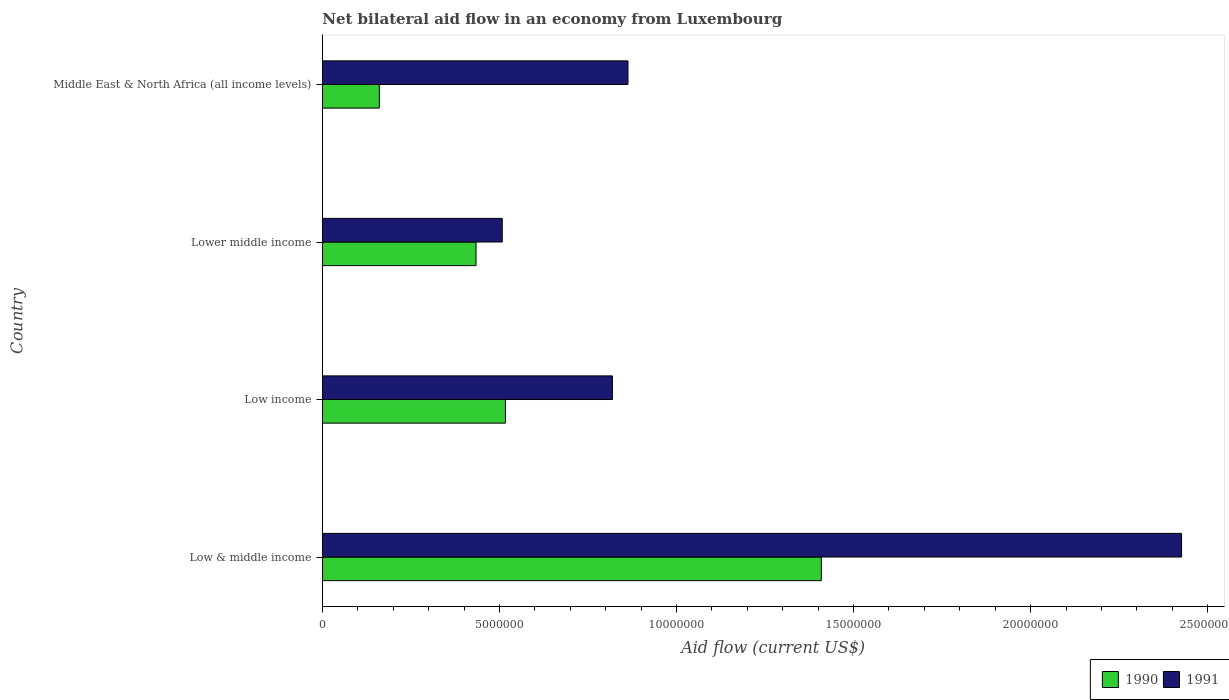How many bars are there on the 3rd tick from the bottom?
Provide a short and direct response. 2. What is the label of the 2nd group of bars from the top?
Your answer should be very brief. Lower middle income. What is the net bilateral aid flow in 1991 in Middle East & North Africa (all income levels)?
Your answer should be very brief. 8.63e+06. Across all countries, what is the maximum net bilateral aid flow in 1990?
Your response must be concise. 1.41e+07. Across all countries, what is the minimum net bilateral aid flow in 1991?
Provide a short and direct response. 5.08e+06. In which country was the net bilateral aid flow in 1990 minimum?
Offer a very short reply. Middle East & North Africa (all income levels). What is the total net bilateral aid flow in 1990 in the graph?
Give a very brief answer. 2.52e+07. What is the difference between the net bilateral aid flow in 1990 in Low & middle income and that in Low income?
Give a very brief answer. 8.92e+06. What is the difference between the net bilateral aid flow in 1990 in Lower middle income and the net bilateral aid flow in 1991 in Middle East & North Africa (all income levels)?
Provide a succinct answer. -4.29e+06. What is the average net bilateral aid flow in 1991 per country?
Ensure brevity in your answer.  1.15e+07. What is the difference between the net bilateral aid flow in 1991 and net bilateral aid flow in 1990 in Low income?
Your response must be concise. 3.02e+06. In how many countries, is the net bilateral aid flow in 1991 greater than 16000000 US$?
Your answer should be compact. 1. What is the ratio of the net bilateral aid flow in 1990 in Low income to that in Lower middle income?
Ensure brevity in your answer.  1.19. Is the net bilateral aid flow in 1990 in Low & middle income less than that in Lower middle income?
Offer a very short reply. No. What is the difference between the highest and the second highest net bilateral aid flow in 1990?
Ensure brevity in your answer.  8.92e+06. What is the difference between the highest and the lowest net bilateral aid flow in 1990?
Give a very brief answer. 1.25e+07. In how many countries, is the net bilateral aid flow in 1990 greater than the average net bilateral aid flow in 1990 taken over all countries?
Your answer should be compact. 1. Is the sum of the net bilateral aid flow in 1990 in Low & middle income and Lower middle income greater than the maximum net bilateral aid flow in 1991 across all countries?
Ensure brevity in your answer.  No. What does the 2nd bar from the top in Lower middle income represents?
Your answer should be compact. 1990. How many bars are there?
Offer a terse response. 8. How many countries are there in the graph?
Provide a short and direct response. 4. What is the difference between two consecutive major ticks on the X-axis?
Give a very brief answer. 5.00e+06. Does the graph contain grids?
Your response must be concise. No. Where does the legend appear in the graph?
Your response must be concise. Bottom right. How many legend labels are there?
Provide a succinct answer. 2. What is the title of the graph?
Offer a terse response. Net bilateral aid flow in an economy from Luxembourg. Does "1969" appear as one of the legend labels in the graph?
Provide a short and direct response. No. What is the label or title of the X-axis?
Offer a terse response. Aid flow (current US$). What is the label or title of the Y-axis?
Make the answer very short. Country. What is the Aid flow (current US$) of 1990 in Low & middle income?
Give a very brief answer. 1.41e+07. What is the Aid flow (current US$) in 1991 in Low & middle income?
Offer a terse response. 2.43e+07. What is the Aid flow (current US$) in 1990 in Low income?
Provide a short and direct response. 5.17e+06. What is the Aid flow (current US$) in 1991 in Low income?
Keep it short and to the point. 8.19e+06. What is the Aid flow (current US$) of 1990 in Lower middle income?
Your response must be concise. 4.34e+06. What is the Aid flow (current US$) of 1991 in Lower middle income?
Provide a succinct answer. 5.08e+06. What is the Aid flow (current US$) in 1990 in Middle East & North Africa (all income levels)?
Offer a terse response. 1.61e+06. What is the Aid flow (current US$) of 1991 in Middle East & North Africa (all income levels)?
Make the answer very short. 8.63e+06. Across all countries, what is the maximum Aid flow (current US$) of 1990?
Make the answer very short. 1.41e+07. Across all countries, what is the maximum Aid flow (current US$) of 1991?
Provide a short and direct response. 2.43e+07. Across all countries, what is the minimum Aid flow (current US$) of 1990?
Give a very brief answer. 1.61e+06. Across all countries, what is the minimum Aid flow (current US$) in 1991?
Ensure brevity in your answer.  5.08e+06. What is the total Aid flow (current US$) of 1990 in the graph?
Provide a succinct answer. 2.52e+07. What is the total Aid flow (current US$) in 1991 in the graph?
Offer a terse response. 4.62e+07. What is the difference between the Aid flow (current US$) of 1990 in Low & middle income and that in Low income?
Keep it short and to the point. 8.92e+06. What is the difference between the Aid flow (current US$) in 1991 in Low & middle income and that in Low income?
Your response must be concise. 1.61e+07. What is the difference between the Aid flow (current US$) of 1990 in Low & middle income and that in Lower middle income?
Keep it short and to the point. 9.75e+06. What is the difference between the Aid flow (current US$) in 1991 in Low & middle income and that in Lower middle income?
Keep it short and to the point. 1.92e+07. What is the difference between the Aid flow (current US$) in 1990 in Low & middle income and that in Middle East & North Africa (all income levels)?
Your answer should be compact. 1.25e+07. What is the difference between the Aid flow (current US$) in 1991 in Low & middle income and that in Middle East & North Africa (all income levels)?
Provide a short and direct response. 1.56e+07. What is the difference between the Aid flow (current US$) in 1990 in Low income and that in Lower middle income?
Keep it short and to the point. 8.30e+05. What is the difference between the Aid flow (current US$) of 1991 in Low income and that in Lower middle income?
Your answer should be compact. 3.11e+06. What is the difference between the Aid flow (current US$) of 1990 in Low income and that in Middle East & North Africa (all income levels)?
Your answer should be very brief. 3.56e+06. What is the difference between the Aid flow (current US$) of 1991 in Low income and that in Middle East & North Africa (all income levels)?
Provide a short and direct response. -4.40e+05. What is the difference between the Aid flow (current US$) in 1990 in Lower middle income and that in Middle East & North Africa (all income levels)?
Provide a succinct answer. 2.73e+06. What is the difference between the Aid flow (current US$) in 1991 in Lower middle income and that in Middle East & North Africa (all income levels)?
Provide a succinct answer. -3.55e+06. What is the difference between the Aid flow (current US$) of 1990 in Low & middle income and the Aid flow (current US$) of 1991 in Low income?
Offer a very short reply. 5.90e+06. What is the difference between the Aid flow (current US$) of 1990 in Low & middle income and the Aid flow (current US$) of 1991 in Lower middle income?
Provide a succinct answer. 9.01e+06. What is the difference between the Aid flow (current US$) of 1990 in Low & middle income and the Aid flow (current US$) of 1991 in Middle East & North Africa (all income levels)?
Give a very brief answer. 5.46e+06. What is the difference between the Aid flow (current US$) of 1990 in Low income and the Aid flow (current US$) of 1991 in Lower middle income?
Provide a succinct answer. 9.00e+04. What is the difference between the Aid flow (current US$) in 1990 in Low income and the Aid flow (current US$) in 1991 in Middle East & North Africa (all income levels)?
Your response must be concise. -3.46e+06. What is the difference between the Aid flow (current US$) in 1990 in Lower middle income and the Aid flow (current US$) in 1991 in Middle East & North Africa (all income levels)?
Make the answer very short. -4.29e+06. What is the average Aid flow (current US$) of 1990 per country?
Your answer should be very brief. 6.30e+06. What is the average Aid flow (current US$) of 1991 per country?
Offer a very short reply. 1.15e+07. What is the difference between the Aid flow (current US$) in 1990 and Aid flow (current US$) in 1991 in Low & middle income?
Keep it short and to the point. -1.02e+07. What is the difference between the Aid flow (current US$) in 1990 and Aid flow (current US$) in 1991 in Low income?
Your answer should be compact. -3.02e+06. What is the difference between the Aid flow (current US$) of 1990 and Aid flow (current US$) of 1991 in Lower middle income?
Provide a short and direct response. -7.40e+05. What is the difference between the Aid flow (current US$) of 1990 and Aid flow (current US$) of 1991 in Middle East & North Africa (all income levels)?
Your answer should be very brief. -7.02e+06. What is the ratio of the Aid flow (current US$) of 1990 in Low & middle income to that in Low income?
Your answer should be very brief. 2.73. What is the ratio of the Aid flow (current US$) in 1991 in Low & middle income to that in Low income?
Provide a succinct answer. 2.96. What is the ratio of the Aid flow (current US$) in 1990 in Low & middle income to that in Lower middle income?
Ensure brevity in your answer.  3.25. What is the ratio of the Aid flow (current US$) in 1991 in Low & middle income to that in Lower middle income?
Make the answer very short. 4.78. What is the ratio of the Aid flow (current US$) of 1990 in Low & middle income to that in Middle East & North Africa (all income levels)?
Offer a very short reply. 8.75. What is the ratio of the Aid flow (current US$) of 1991 in Low & middle income to that in Middle East & North Africa (all income levels)?
Ensure brevity in your answer.  2.81. What is the ratio of the Aid flow (current US$) in 1990 in Low income to that in Lower middle income?
Make the answer very short. 1.19. What is the ratio of the Aid flow (current US$) in 1991 in Low income to that in Lower middle income?
Keep it short and to the point. 1.61. What is the ratio of the Aid flow (current US$) in 1990 in Low income to that in Middle East & North Africa (all income levels)?
Provide a short and direct response. 3.21. What is the ratio of the Aid flow (current US$) of 1991 in Low income to that in Middle East & North Africa (all income levels)?
Keep it short and to the point. 0.95. What is the ratio of the Aid flow (current US$) of 1990 in Lower middle income to that in Middle East & North Africa (all income levels)?
Provide a succinct answer. 2.7. What is the ratio of the Aid flow (current US$) of 1991 in Lower middle income to that in Middle East & North Africa (all income levels)?
Make the answer very short. 0.59. What is the difference between the highest and the second highest Aid flow (current US$) of 1990?
Ensure brevity in your answer.  8.92e+06. What is the difference between the highest and the second highest Aid flow (current US$) of 1991?
Offer a very short reply. 1.56e+07. What is the difference between the highest and the lowest Aid flow (current US$) of 1990?
Keep it short and to the point. 1.25e+07. What is the difference between the highest and the lowest Aid flow (current US$) of 1991?
Make the answer very short. 1.92e+07. 